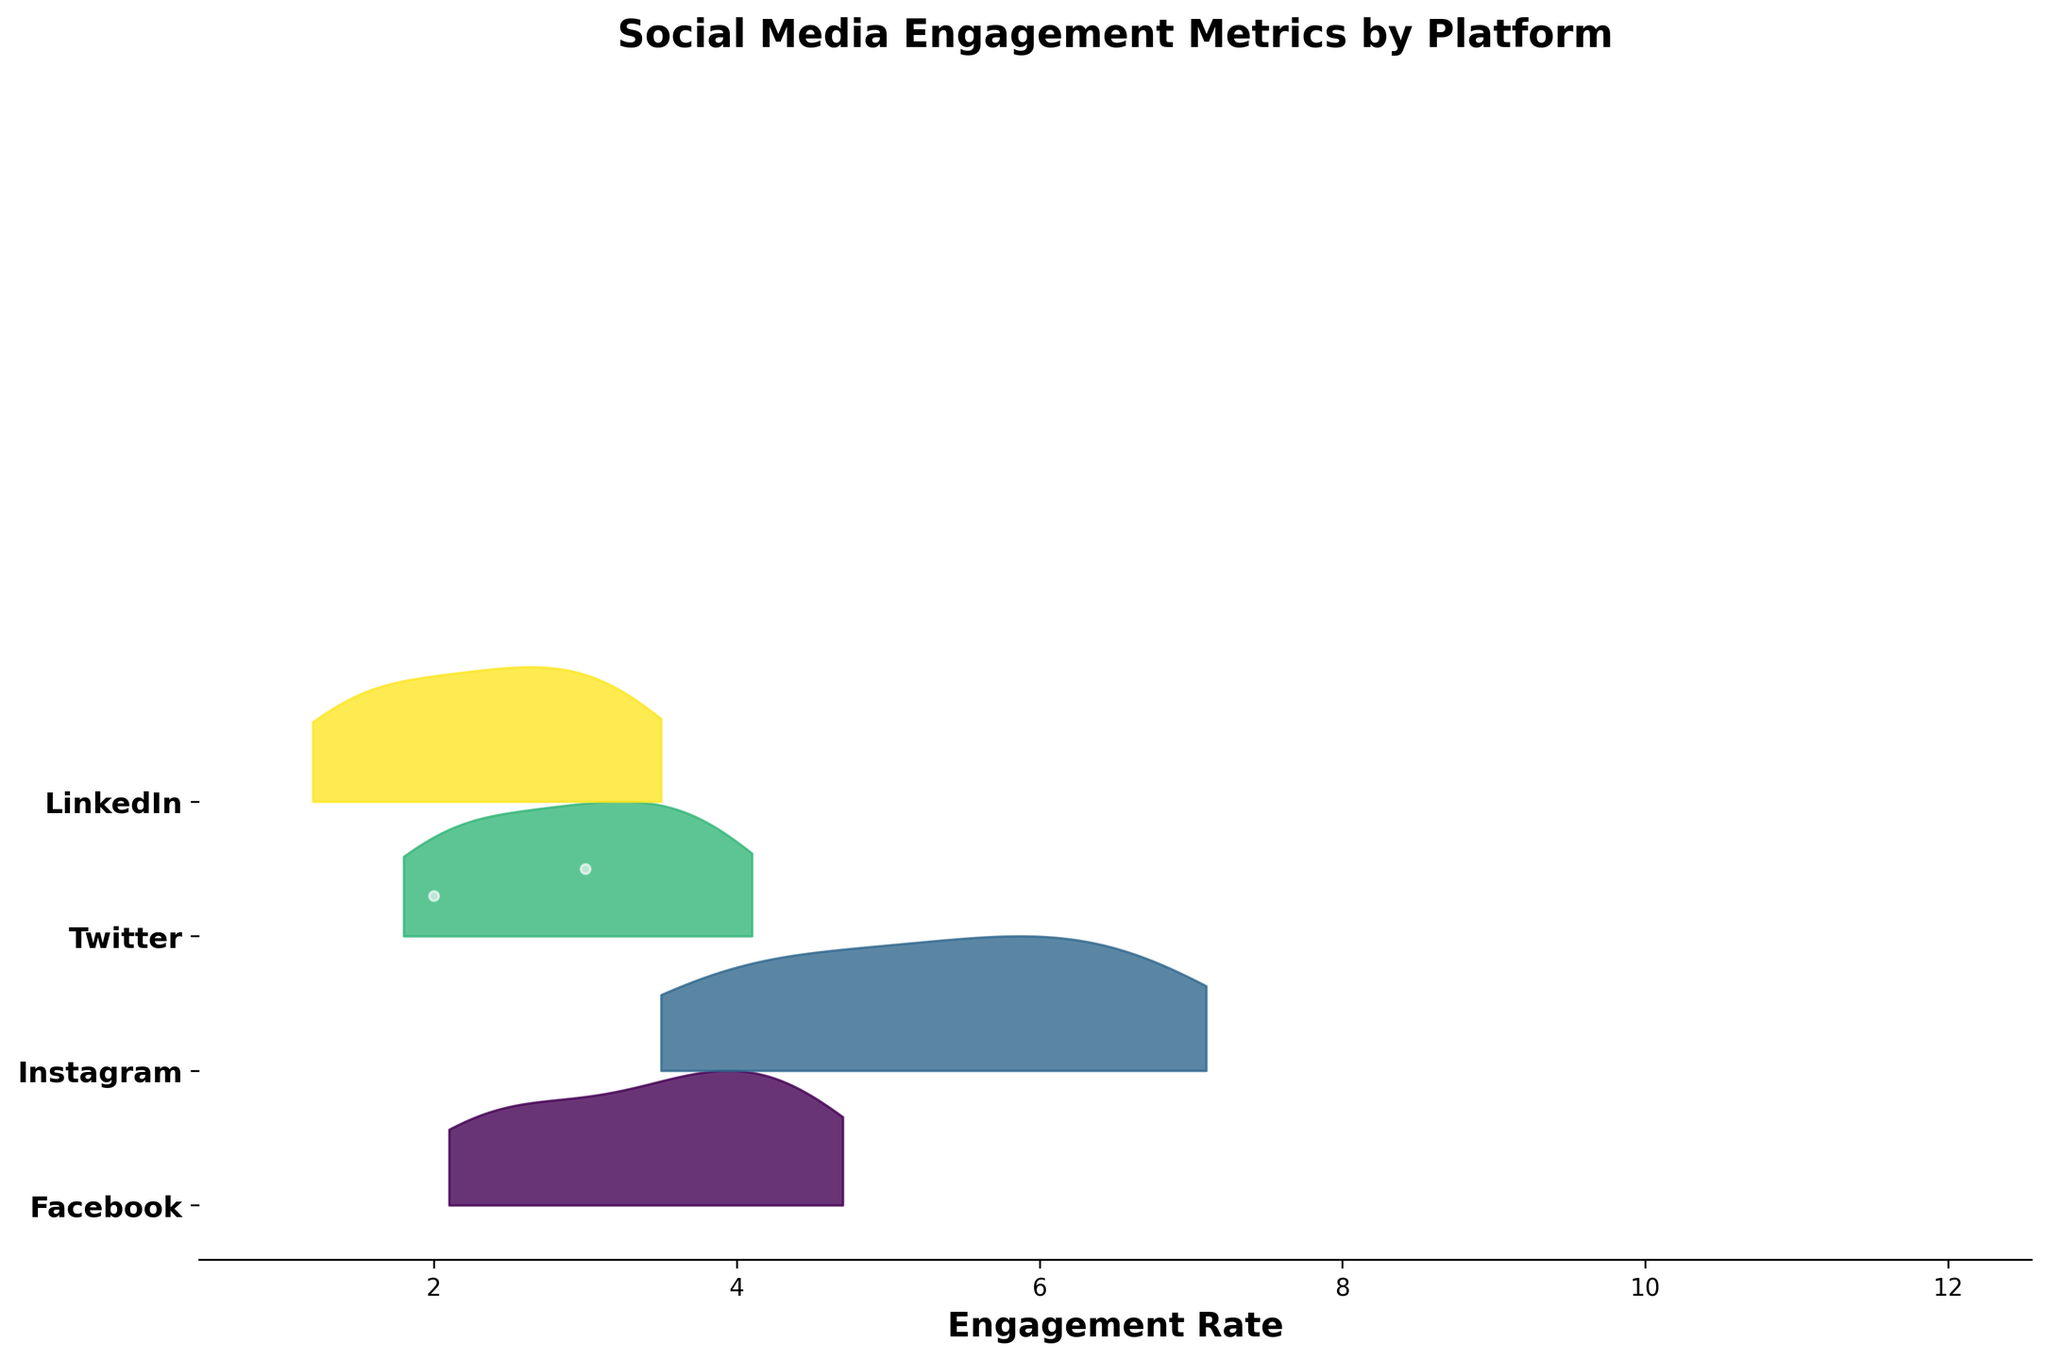What is the title of the plot? The title of the plot is located at the top and it is written in bold font. The title reads 'Social Media Engagement Metrics by Platform'.
Answer: Social Media Engagement Metrics by Platform How many different social media platforms are shown in the plot? The y-axis of the plot lists the social media platforms with tick marks. By counting the labels, one can see there are four platforms.
Answer: 4 Which platform had the highest engagement rate trend in the given quarter? Looking at the plot, Instagram shows the highest engagement rate trend as its lines and filled ridgeline appears highest up in the engagement rate scale.
Answer: Instagram Between which weeks does LinkedIn show a rapid increase in the engagement rate? By examining the plot, LinkedIn shows a noticeable increase from week 8 to week 12. The ridgeline gets significantly higher, indicating increased engagement rates.
Answer: Between week 8 and week 12 Which platform's engagement rate shows steady growth throughout the quarter? By comparing the shapes and trends of the ridgeline filled areas, Twitter and Facebook show steady and consistent upward trends throughout the entire quarter.
Answer: Twitter and Facebook What is the range of engagement rates for Facebook during the quarter? The engagement rate for Facebook starts at 2.1 and ends at 4.7 during the quarter. This can be observed by the starting and ending points of the line representing Facebook.
Answer: 2.1 to 4.7 Does any platform show a decline in engagement rate in any week during the quarter? Observing the plot, no platform shows a visible decline in engagement rates; all platforms exhibit steady or increasing trends in engagement rates over time.
Answer: No How does Twitter's final week engagement rate compare to Facebook's initial week engagement rate? Comparing the last week engagement rate of Twitter, which is 4.1, to the first week engagement rate of Facebook, which is 2.1, shows Twitter’s final rate is higher.
Answer: Twitter's final rate is higher Between which weeks does Instagram show the highest rate of increase in engagement rate? Examining the plot, Instagram shows the highest increase rate between week 8 and week 12, where the curve rises steeply.
Answer: Between week 8 and week 12 Which platform shows the slowest growth in engagement rate over the quarter? LinkedIn shows the slowest and least steep growth in engagement rate over the quarter, with a relatively flatter ridgeline compared to other platforms.
Answer: LinkedIn 